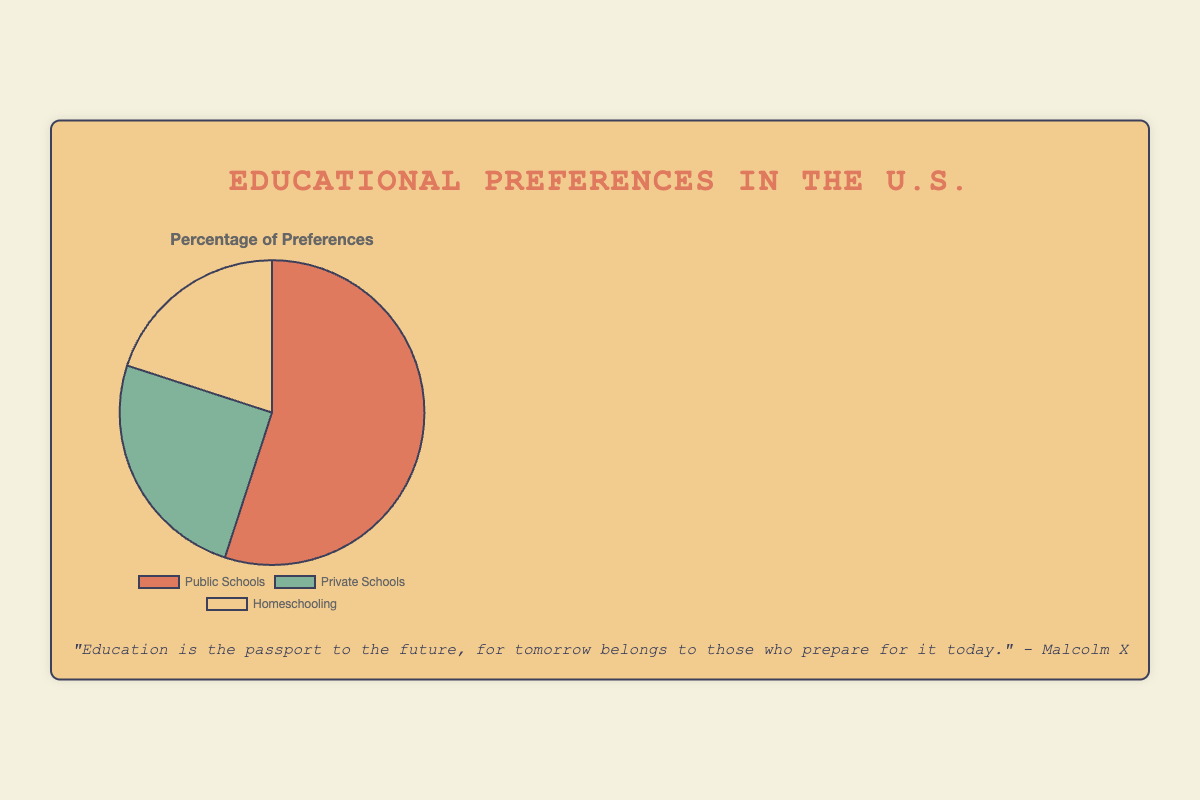Which type of educational institution is preferred by the majority? The pie chart shows three types of educational institutions: Public Schools, Private Schools, and Homeschooling. The largest slice represents Public Schools with 55%, indicating that it is the most preferred type.
Answer: Public Schools What is the total percentage of people preferring either Private Schools or Homeschooling? The percentage for Private Schools is 25% and for Homeschooling is 20%. Adding these together gives 25% + 20% = 45%.
Answer: 45% How does the preference for Public Schools compare to the combined preference for Private Schools and Homeschooling? Public Schools have a preference of 55%, while the combined preference for Private Schools and Homeschooling is 25% + 20% = 45%. Hence, Public Schools have a higher preference by 55% - 45% = 10%.
Answer: Public Schools are preferred more by 10% Which type of educational institution has the smallest preference, and what is its percentage? The smallest slice of the pie chart represents Homeschooling with a preference of 20%.
Answer: Homeschooling with 20% If 1000 people were surveyed, about how many would prefer Homeschooling? 20% of 1000 people is calculated as (20 / 100) * 1000 = 200 people preferring Homeschooling.
Answer: 200 Which type of educational institution has twice the preference compared to Homeschooling? The preference for Homeschooling is 20%. Public Schools have a preference of 55%, which is more than twice, but Private Schools have a preference of 25%, which is slightly more than the Homeschooling percentage.
Answer: None have exactly twice, but Private Schools have 25% What is the difference in preference percentage between the most preferred and least preferred educational institutions? The most preferred is Public Schools at 55%, and the least preferred is Homeschooling at 20%. The difference is 55% - 20% = 35%.
Answer: 35% What percentage of people do not prefer Public Schools? The preference for Public Schools is 55%, thus the percentage of people not preferring it is 100% - 55% = 45%.
Answer: 45% The slice representing Public Schools is visually larger than which other educational institution(s)? The Public Schools slice appears larger than both the Private Schools and Homeschooling slices when comparing their sizes visually.
Answer: Private Schools and Homeschooling If the preferences for Private Schools and Homeschooling were combined into one category, what percentage would it represent relative to Public Schools? Combining Private Schools and Homeschooling gives 25% + 20% = 45%. Public Schools are 55%. This would mean the combined category is 45% relative to Public Schools' 55%.
Answer: 45% relative to 55% 